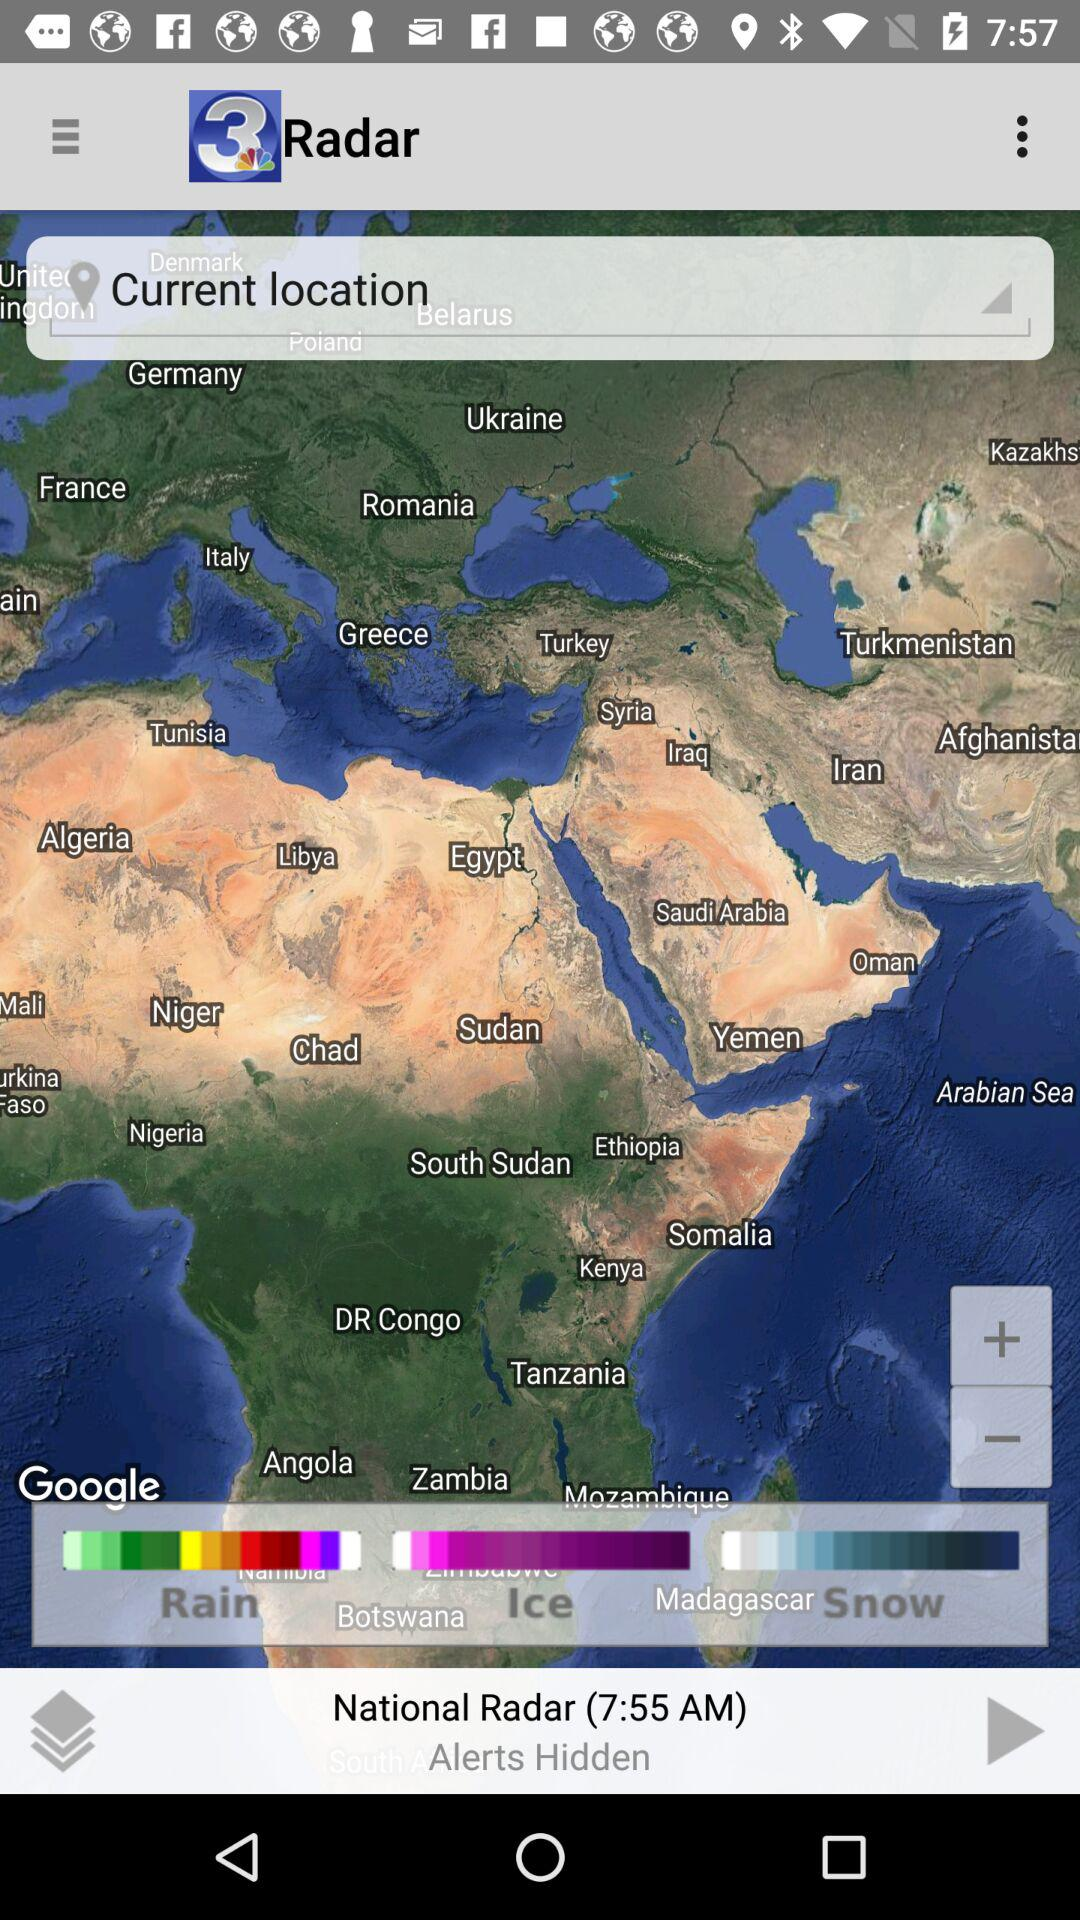Are alerts hidden or not?
Answer the question using a single word or phrase. Alerts are hidden. 